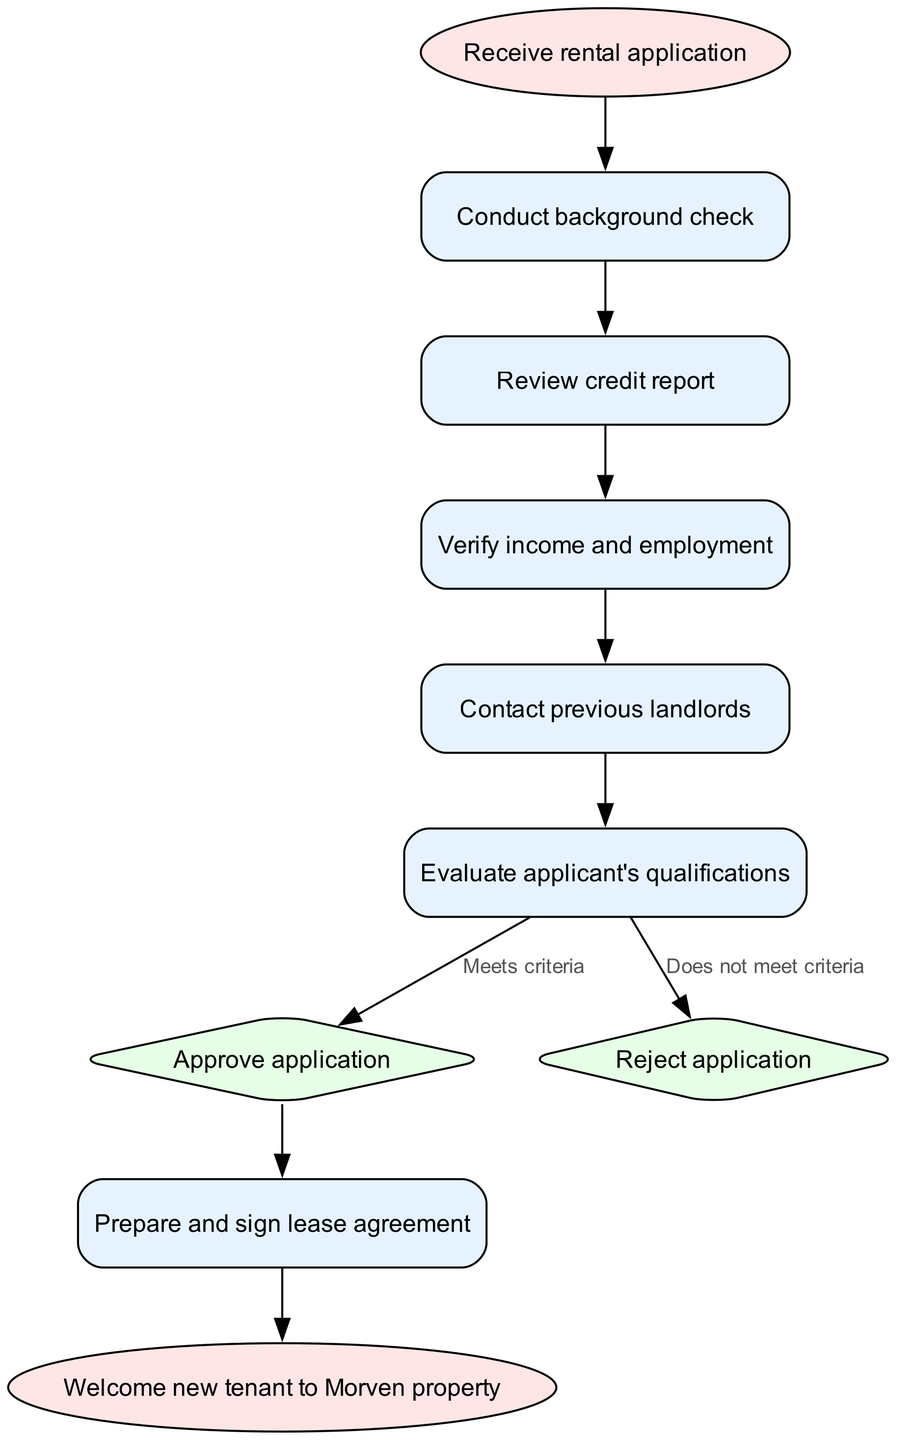What is the first step in the tenant screening process? The diagram indicates that the first step is to "Receive rental application," which is shown at the start node.
Answer: Receive rental application How many nodes are there in the flowchart? By counting all the individual elements (start, background check, credit report, etc.), we can see that there are a total of 10 nodes in the diagram.
Answer: 10 What decision is made after evaluating the applicant's qualifications? After reaching the "Evaluate applicant's qualifications" node, the diagram shows two possible outcomes: "Approve application" or "Reject application." This is indicated by the edges leading from the decision node.
Answer: Approve application or Reject application Which node follows the "Contact previous landlords" step? In the flowchart, the "Contact previous landlords" step leads directly to the "Evaluate applicant's qualifications" step as the next action, as indicated in the flow sequence of the edges.
Answer: Evaluate applicant's qualifications What are the possible outcomes of the decision node? The outcomes are clearly represented in the diagram as "Approve application" and "Reject application," showing a binary decision-making process following the evaluation of the applicant.
Answer: Approve application, Reject application Which node is connected to the "Reject application" decision? The flowchart shows that after rejecting an application, there are no further nodes leading to other steps, indicating a terminal outcome following the rejection at the "Reject application" node.
Answer: None What is the shape of the node that represents the final step in the process? The final step, depicted by the "Welcome new tenant to Morven property," is represented as an oval, indicating it is a terminal node in the flowchart.
Answer: Oval What step comes after "Prepare and sign lease agreement"? According to the diagram, once the lease agreement is prepared and signed, the next and final step is "Welcome new tenant to Morven property," indicating the conclusion of the screening process.
Answer: Welcome new tenant to Morven property What type of check is conducted before reviewing the credit report? The diagram shows that a "background check" is conducted prior to the "Review credit report," indicating the structured order of steps in the screening process.
Answer: Background check What would happen if an application does not meet the criteria? If an application does not meet the criteria during the evaluation, the flowchart directs towards the "Reject application" node, indicating the next action to take based on such a decision.
Answer: Reject application 